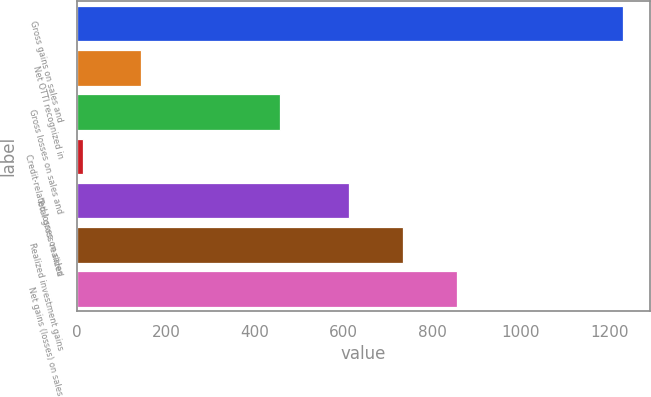Convert chart. <chart><loc_0><loc_0><loc_500><loc_500><bar_chart><fcel>Gross gains on sales and<fcel>Net OTTI recognized in<fcel>Gross losses on sales and<fcel>Credit-related losses on sales<fcel>Total gross realized<fcel>Realized investment gains<fcel>Net gains (losses) on sales<nl><fcel>1229<fcel>144<fcel>456<fcel>12<fcel>612<fcel>733.7<fcel>855.4<nl></chart> 